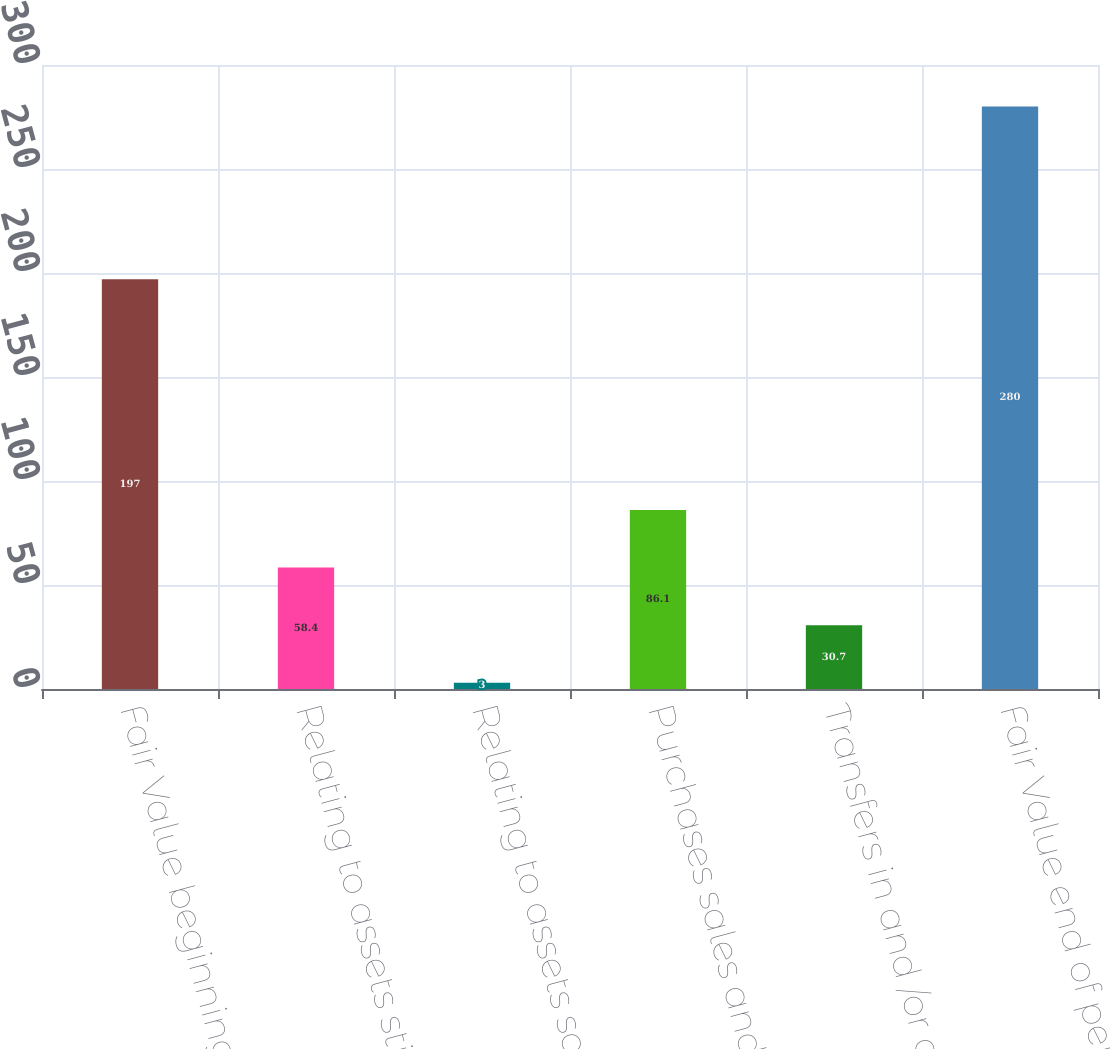<chart> <loc_0><loc_0><loc_500><loc_500><bar_chart><fcel>Fair Value beginning of period<fcel>Relating to assets still held<fcel>Relating to assets sold during<fcel>Purchases sales and<fcel>Transfers in and /or out of<fcel>Fair Value end of period<nl><fcel>197<fcel>58.4<fcel>3<fcel>86.1<fcel>30.7<fcel>280<nl></chart> 